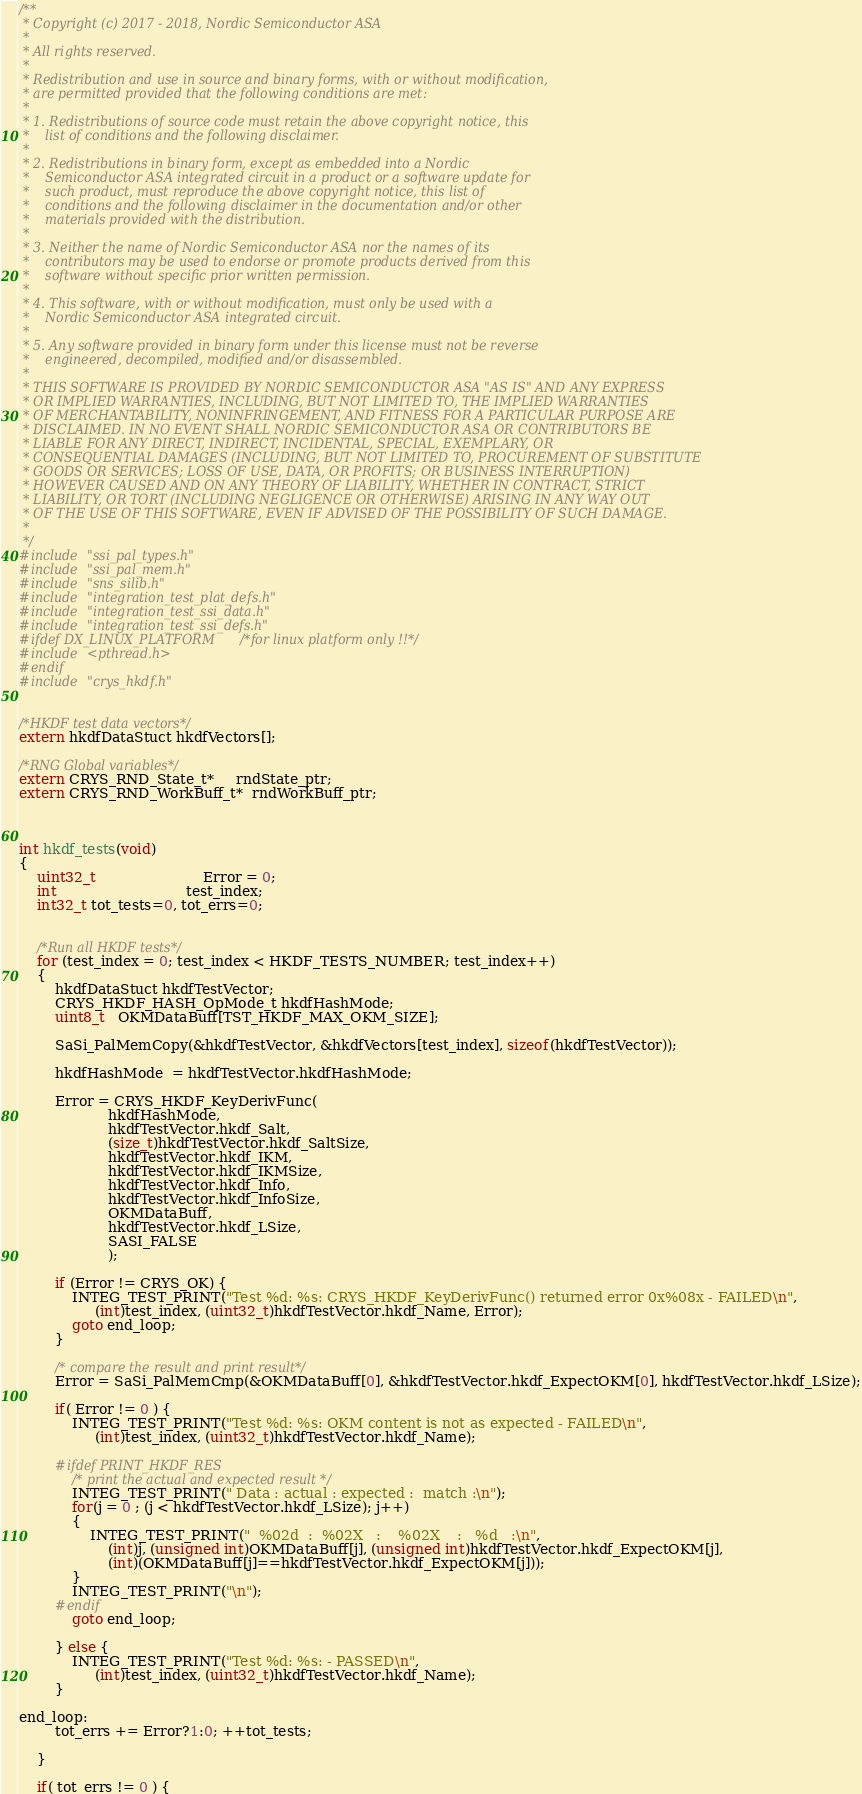<code> <loc_0><loc_0><loc_500><loc_500><_C_>/**
 * Copyright (c) 2017 - 2018, Nordic Semiconductor ASA
 *
 * All rights reserved.
 *
 * Redistribution and use in source and binary forms, with or without modification,
 * are permitted provided that the following conditions are met:
 *
 * 1. Redistributions of source code must retain the above copyright notice, this
 *    list of conditions and the following disclaimer.
 *
 * 2. Redistributions in binary form, except as embedded into a Nordic
 *    Semiconductor ASA integrated circuit in a product or a software update for
 *    such product, must reproduce the above copyright notice, this list of
 *    conditions and the following disclaimer in the documentation and/or other
 *    materials provided with the distribution.
 *
 * 3. Neither the name of Nordic Semiconductor ASA nor the names of its
 *    contributors may be used to endorse or promote products derived from this
 *    software without specific prior written permission.
 *
 * 4. This software, with or without modification, must only be used with a
 *    Nordic Semiconductor ASA integrated circuit.
 *
 * 5. Any software provided in binary form under this license must not be reverse
 *    engineered, decompiled, modified and/or disassembled.
 *
 * THIS SOFTWARE IS PROVIDED BY NORDIC SEMICONDUCTOR ASA "AS IS" AND ANY EXPRESS
 * OR IMPLIED WARRANTIES, INCLUDING, BUT NOT LIMITED TO, THE IMPLIED WARRANTIES
 * OF MERCHANTABILITY, NONINFRINGEMENT, AND FITNESS FOR A PARTICULAR PURPOSE ARE
 * DISCLAIMED. IN NO EVENT SHALL NORDIC SEMICONDUCTOR ASA OR CONTRIBUTORS BE
 * LIABLE FOR ANY DIRECT, INDIRECT, INCIDENTAL, SPECIAL, EXEMPLARY, OR
 * CONSEQUENTIAL DAMAGES (INCLUDING, BUT NOT LIMITED TO, PROCUREMENT OF SUBSTITUTE
 * GOODS OR SERVICES; LOSS OF USE, DATA, OR PROFITS; OR BUSINESS INTERRUPTION)
 * HOWEVER CAUSED AND ON ANY THEORY OF LIABILITY, WHETHER IN CONTRACT, STRICT
 * LIABILITY, OR TORT (INCLUDING NEGLIGENCE OR OTHERWISE) ARISING IN ANY WAY OUT
 * OF THE USE OF THIS SOFTWARE, EVEN IF ADVISED OF THE POSSIBILITY OF SUCH DAMAGE.
 *
 */
#include "ssi_pal_types.h"
#include "ssi_pal_mem.h"
#include "sns_silib.h"
#include "integration_test_plat_defs.h"
#include "integration_test_ssi_data.h"
#include "integration_test_ssi_defs.h"
#ifdef DX_LINUX_PLATFORM /*for linux platform only !!*/
#include <pthread.h>
#endif
#include "crys_hkdf.h"


/*HKDF test data vectors*/
extern hkdfDataStuct hkdfVectors[];

/*RNG Global variables*/
extern CRYS_RND_State_t*     rndState_ptr;
extern CRYS_RND_WorkBuff_t*  rndWorkBuff_ptr;



int hkdf_tests(void)
{
	uint32_t                        Error = 0;
	int                             test_index;
 	int32_t tot_tests=0, tot_errs=0;


	/*Run all HKDF tests*/
	for (test_index = 0; test_index < HKDF_TESTS_NUMBER; test_index++)
	{
		hkdfDataStuct hkdfTestVector;
		CRYS_HKDF_HASH_OpMode_t hkdfHashMode;
		uint8_t   OKMDataBuff[TST_HKDF_MAX_OKM_SIZE];

		SaSi_PalMemCopy(&hkdfTestVector, &hkdfVectors[test_index], sizeof(hkdfTestVector));

		hkdfHashMode  = hkdfTestVector.hkdfHashMode;

		Error = CRYS_HKDF_KeyDerivFunc(
					hkdfHashMode,
					hkdfTestVector.hkdf_Salt,
					(size_t)hkdfTestVector.hkdf_SaltSize,
					hkdfTestVector.hkdf_IKM,
					hkdfTestVector.hkdf_IKMSize,
					hkdfTestVector.hkdf_Info,
					hkdfTestVector.hkdf_InfoSize,
					OKMDataBuff,
					hkdfTestVector.hkdf_LSize,
					SASI_FALSE
					);

		if (Error != CRYS_OK) {
			INTEG_TEST_PRINT("Test %d: %s: CRYS_HKDF_KeyDerivFunc() returned error 0x%08x - FAILED\n",
				 (int)test_index, (uint32_t)hkdfTestVector.hkdf_Name, Error);
			goto end_loop;
		}

		/* compare the result and print result*/
		Error = SaSi_PalMemCmp(&OKMDataBuff[0], &hkdfTestVector.hkdf_ExpectOKM[0], hkdfTestVector.hkdf_LSize);

		if( Error != 0 ) {
			INTEG_TEST_PRINT("Test %d: %s: OKM content is not as expected - FAILED\n",
				 (int)test_index, (uint32_t)hkdfTestVector.hkdf_Name);

		#ifdef PRINT_HKDF_RES
			/* print the actual and expected result */
			INTEG_TEST_PRINT(" Data : actual : expected :  match :\n");
			for(j = 0 ; (j < hkdfTestVector.hkdf_LSize); j++)
			{
				INTEG_TEST_PRINT("  %02d  :  %02X   :    %02X    :   %d   :\n",
					(int)j, (unsigned int)OKMDataBuff[j], (unsigned int)hkdfTestVector.hkdf_ExpectOKM[j],
					(int)(OKMDataBuff[j]==hkdfTestVector.hkdf_ExpectOKM[j]));
			}
			INTEG_TEST_PRINT("\n");
		#endif
			goto end_loop;

		} else {
			INTEG_TEST_PRINT("Test %d: %s: - PASSED\n",
				 (int)test_index, (uint32_t)hkdfTestVector.hkdf_Name);
		}

end_loop:
		tot_errs += Error?1:0; ++tot_tests;

	}

	if( tot_errs != 0 ) {</code> 